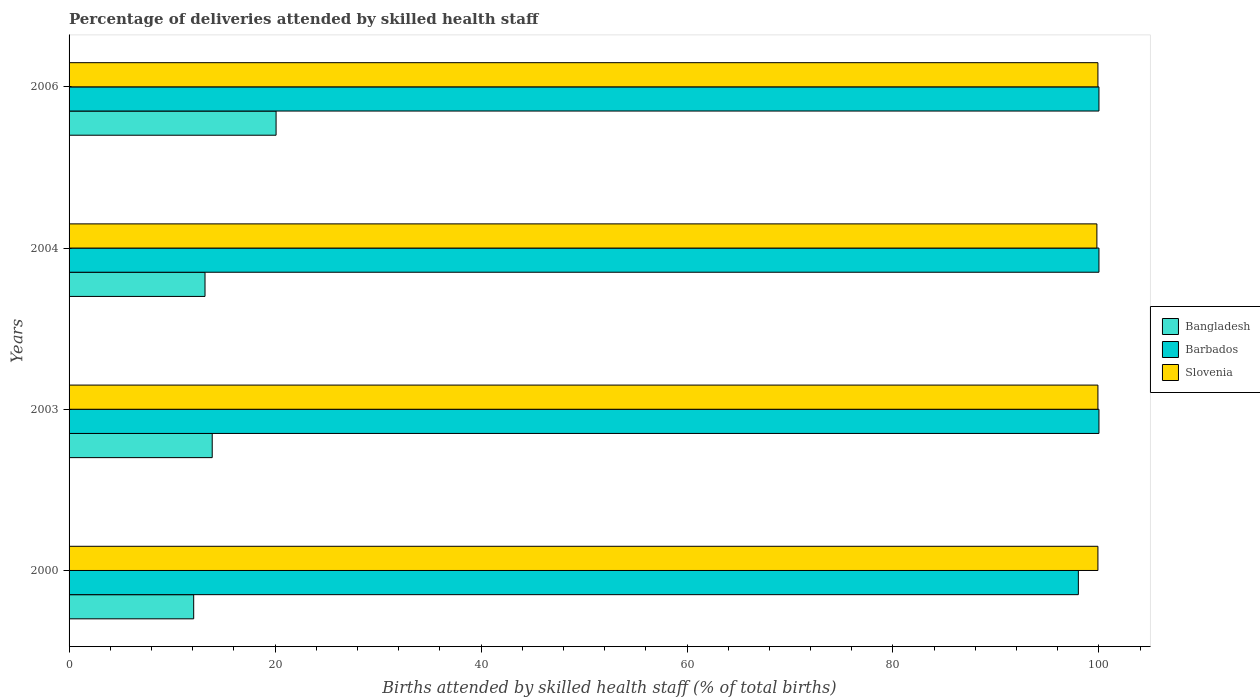Are the number of bars per tick equal to the number of legend labels?
Your answer should be very brief. Yes. Are the number of bars on each tick of the Y-axis equal?
Offer a very short reply. Yes. How many bars are there on the 1st tick from the top?
Provide a succinct answer. 3. What is the label of the 1st group of bars from the top?
Give a very brief answer. 2006. In how many cases, is the number of bars for a given year not equal to the number of legend labels?
Offer a terse response. 0. What is the percentage of births attended by skilled health staff in Bangladesh in 2003?
Provide a short and direct response. 13.9. Across all years, what is the maximum percentage of births attended by skilled health staff in Bangladesh?
Offer a terse response. 20.1. Across all years, what is the minimum percentage of births attended by skilled health staff in Bangladesh?
Offer a terse response. 12.1. In which year was the percentage of births attended by skilled health staff in Barbados minimum?
Ensure brevity in your answer.  2000. What is the total percentage of births attended by skilled health staff in Bangladesh in the graph?
Your response must be concise. 59.3. What is the difference between the percentage of births attended by skilled health staff in Slovenia in 2004 and the percentage of births attended by skilled health staff in Bangladesh in 2003?
Offer a very short reply. 85.9. What is the average percentage of births attended by skilled health staff in Barbados per year?
Your response must be concise. 99.5. In the year 2000, what is the difference between the percentage of births attended by skilled health staff in Barbados and percentage of births attended by skilled health staff in Bangladesh?
Ensure brevity in your answer.  85.9. In how many years, is the percentage of births attended by skilled health staff in Bangladesh greater than 96 %?
Make the answer very short. 0. Is the percentage of births attended by skilled health staff in Bangladesh in 2000 less than that in 2004?
Offer a terse response. Yes. Is the difference between the percentage of births attended by skilled health staff in Barbados in 2004 and 2006 greater than the difference between the percentage of births attended by skilled health staff in Bangladesh in 2004 and 2006?
Give a very brief answer. Yes. What is the difference between the highest and the second highest percentage of births attended by skilled health staff in Barbados?
Provide a short and direct response. 0. What is the difference between the highest and the lowest percentage of births attended by skilled health staff in Slovenia?
Offer a terse response. 0.1. What does the 1st bar from the top in 2006 represents?
Provide a succinct answer. Slovenia. What does the 3rd bar from the bottom in 2000 represents?
Your response must be concise. Slovenia. How many bars are there?
Your answer should be very brief. 12. Are the values on the major ticks of X-axis written in scientific E-notation?
Your answer should be very brief. No. Does the graph contain grids?
Your response must be concise. No. How are the legend labels stacked?
Your response must be concise. Vertical. What is the title of the graph?
Provide a succinct answer. Percentage of deliveries attended by skilled health staff. Does "Iraq" appear as one of the legend labels in the graph?
Give a very brief answer. No. What is the label or title of the X-axis?
Your answer should be very brief. Births attended by skilled health staff (% of total births). What is the Births attended by skilled health staff (% of total births) in Barbados in 2000?
Provide a short and direct response. 98. What is the Births attended by skilled health staff (% of total births) in Slovenia in 2000?
Keep it short and to the point. 99.9. What is the Births attended by skilled health staff (% of total births) of Bangladesh in 2003?
Provide a succinct answer. 13.9. What is the Births attended by skilled health staff (% of total births) of Barbados in 2003?
Your answer should be compact. 100. What is the Births attended by skilled health staff (% of total births) in Slovenia in 2003?
Offer a terse response. 99.9. What is the Births attended by skilled health staff (% of total births) in Barbados in 2004?
Ensure brevity in your answer.  100. What is the Births attended by skilled health staff (% of total births) of Slovenia in 2004?
Provide a short and direct response. 99.8. What is the Births attended by skilled health staff (% of total births) in Bangladesh in 2006?
Ensure brevity in your answer.  20.1. What is the Births attended by skilled health staff (% of total births) of Barbados in 2006?
Offer a very short reply. 100. What is the Births attended by skilled health staff (% of total births) in Slovenia in 2006?
Provide a succinct answer. 99.9. Across all years, what is the maximum Births attended by skilled health staff (% of total births) of Bangladesh?
Offer a very short reply. 20.1. Across all years, what is the maximum Births attended by skilled health staff (% of total births) of Barbados?
Provide a succinct answer. 100. Across all years, what is the maximum Births attended by skilled health staff (% of total births) in Slovenia?
Offer a very short reply. 99.9. Across all years, what is the minimum Births attended by skilled health staff (% of total births) of Bangladesh?
Your answer should be very brief. 12.1. Across all years, what is the minimum Births attended by skilled health staff (% of total births) of Slovenia?
Offer a very short reply. 99.8. What is the total Births attended by skilled health staff (% of total births) in Bangladesh in the graph?
Provide a short and direct response. 59.3. What is the total Births attended by skilled health staff (% of total births) of Barbados in the graph?
Keep it short and to the point. 398. What is the total Births attended by skilled health staff (% of total births) in Slovenia in the graph?
Provide a succinct answer. 399.5. What is the difference between the Births attended by skilled health staff (% of total births) in Barbados in 2000 and that in 2003?
Make the answer very short. -2. What is the difference between the Births attended by skilled health staff (% of total births) in Bangladesh in 2000 and that in 2004?
Offer a very short reply. -1.1. What is the difference between the Births attended by skilled health staff (% of total births) of Barbados in 2000 and that in 2004?
Make the answer very short. -2. What is the difference between the Births attended by skilled health staff (% of total births) of Bangladesh in 2000 and that in 2006?
Offer a very short reply. -8. What is the difference between the Births attended by skilled health staff (% of total births) of Barbados in 2000 and that in 2006?
Offer a very short reply. -2. What is the difference between the Births attended by skilled health staff (% of total births) of Slovenia in 2000 and that in 2006?
Give a very brief answer. 0. What is the difference between the Births attended by skilled health staff (% of total births) of Barbados in 2003 and that in 2004?
Your response must be concise. 0. What is the difference between the Births attended by skilled health staff (% of total births) in Slovenia in 2003 and that in 2004?
Your response must be concise. 0.1. What is the difference between the Births attended by skilled health staff (% of total births) in Bangladesh in 2003 and that in 2006?
Ensure brevity in your answer.  -6.2. What is the difference between the Births attended by skilled health staff (% of total births) in Barbados in 2003 and that in 2006?
Offer a very short reply. 0. What is the difference between the Births attended by skilled health staff (% of total births) of Bangladesh in 2000 and the Births attended by skilled health staff (% of total births) of Barbados in 2003?
Make the answer very short. -87.9. What is the difference between the Births attended by skilled health staff (% of total births) in Bangladesh in 2000 and the Births attended by skilled health staff (% of total births) in Slovenia in 2003?
Provide a short and direct response. -87.8. What is the difference between the Births attended by skilled health staff (% of total births) in Barbados in 2000 and the Births attended by skilled health staff (% of total births) in Slovenia in 2003?
Give a very brief answer. -1.9. What is the difference between the Births attended by skilled health staff (% of total births) in Bangladesh in 2000 and the Births attended by skilled health staff (% of total births) in Barbados in 2004?
Give a very brief answer. -87.9. What is the difference between the Births attended by skilled health staff (% of total births) in Bangladesh in 2000 and the Births attended by skilled health staff (% of total births) in Slovenia in 2004?
Your answer should be compact. -87.7. What is the difference between the Births attended by skilled health staff (% of total births) of Barbados in 2000 and the Births attended by skilled health staff (% of total births) of Slovenia in 2004?
Your answer should be very brief. -1.8. What is the difference between the Births attended by skilled health staff (% of total births) in Bangladesh in 2000 and the Births attended by skilled health staff (% of total births) in Barbados in 2006?
Offer a terse response. -87.9. What is the difference between the Births attended by skilled health staff (% of total births) of Bangladesh in 2000 and the Births attended by skilled health staff (% of total births) of Slovenia in 2006?
Offer a very short reply. -87.8. What is the difference between the Births attended by skilled health staff (% of total births) of Barbados in 2000 and the Births attended by skilled health staff (% of total births) of Slovenia in 2006?
Provide a succinct answer. -1.9. What is the difference between the Births attended by skilled health staff (% of total births) of Bangladesh in 2003 and the Births attended by skilled health staff (% of total births) of Barbados in 2004?
Make the answer very short. -86.1. What is the difference between the Births attended by skilled health staff (% of total births) of Bangladesh in 2003 and the Births attended by skilled health staff (% of total births) of Slovenia in 2004?
Your response must be concise. -85.9. What is the difference between the Births attended by skilled health staff (% of total births) in Bangladesh in 2003 and the Births attended by skilled health staff (% of total births) in Barbados in 2006?
Offer a terse response. -86.1. What is the difference between the Births attended by skilled health staff (% of total births) of Bangladesh in 2003 and the Births attended by skilled health staff (% of total births) of Slovenia in 2006?
Give a very brief answer. -86. What is the difference between the Births attended by skilled health staff (% of total births) of Bangladesh in 2004 and the Births attended by skilled health staff (% of total births) of Barbados in 2006?
Provide a succinct answer. -86.8. What is the difference between the Births attended by skilled health staff (% of total births) in Bangladesh in 2004 and the Births attended by skilled health staff (% of total births) in Slovenia in 2006?
Keep it short and to the point. -86.7. What is the difference between the Births attended by skilled health staff (% of total births) of Barbados in 2004 and the Births attended by skilled health staff (% of total births) of Slovenia in 2006?
Offer a terse response. 0.1. What is the average Births attended by skilled health staff (% of total births) in Bangladesh per year?
Your answer should be very brief. 14.82. What is the average Births attended by skilled health staff (% of total births) in Barbados per year?
Offer a terse response. 99.5. What is the average Births attended by skilled health staff (% of total births) in Slovenia per year?
Your answer should be very brief. 99.88. In the year 2000, what is the difference between the Births attended by skilled health staff (% of total births) of Bangladesh and Births attended by skilled health staff (% of total births) of Barbados?
Provide a short and direct response. -85.9. In the year 2000, what is the difference between the Births attended by skilled health staff (% of total births) in Bangladesh and Births attended by skilled health staff (% of total births) in Slovenia?
Your answer should be very brief. -87.8. In the year 2003, what is the difference between the Births attended by skilled health staff (% of total births) in Bangladesh and Births attended by skilled health staff (% of total births) in Barbados?
Keep it short and to the point. -86.1. In the year 2003, what is the difference between the Births attended by skilled health staff (% of total births) of Bangladesh and Births attended by skilled health staff (% of total births) of Slovenia?
Your response must be concise. -86. In the year 2003, what is the difference between the Births attended by skilled health staff (% of total births) in Barbados and Births attended by skilled health staff (% of total births) in Slovenia?
Provide a succinct answer. 0.1. In the year 2004, what is the difference between the Births attended by skilled health staff (% of total births) in Bangladesh and Births attended by skilled health staff (% of total births) in Barbados?
Offer a terse response. -86.8. In the year 2004, what is the difference between the Births attended by skilled health staff (% of total births) of Bangladesh and Births attended by skilled health staff (% of total births) of Slovenia?
Provide a short and direct response. -86.6. In the year 2006, what is the difference between the Births attended by skilled health staff (% of total births) in Bangladesh and Births attended by skilled health staff (% of total births) in Barbados?
Your answer should be very brief. -79.9. In the year 2006, what is the difference between the Births attended by skilled health staff (% of total births) in Bangladesh and Births attended by skilled health staff (% of total births) in Slovenia?
Provide a succinct answer. -79.8. What is the ratio of the Births attended by skilled health staff (% of total births) in Bangladesh in 2000 to that in 2003?
Offer a very short reply. 0.87. What is the ratio of the Births attended by skilled health staff (% of total births) in Barbados in 2000 to that in 2003?
Your answer should be compact. 0.98. What is the ratio of the Births attended by skilled health staff (% of total births) of Slovenia in 2000 to that in 2003?
Provide a short and direct response. 1. What is the ratio of the Births attended by skilled health staff (% of total births) in Bangladesh in 2000 to that in 2004?
Your answer should be very brief. 0.92. What is the ratio of the Births attended by skilled health staff (% of total births) of Slovenia in 2000 to that in 2004?
Provide a succinct answer. 1. What is the ratio of the Births attended by skilled health staff (% of total births) in Bangladesh in 2000 to that in 2006?
Offer a very short reply. 0.6. What is the ratio of the Births attended by skilled health staff (% of total births) of Bangladesh in 2003 to that in 2004?
Give a very brief answer. 1.05. What is the ratio of the Births attended by skilled health staff (% of total births) in Barbados in 2003 to that in 2004?
Offer a terse response. 1. What is the ratio of the Births attended by skilled health staff (% of total births) in Bangladesh in 2003 to that in 2006?
Offer a very short reply. 0.69. What is the ratio of the Births attended by skilled health staff (% of total births) in Barbados in 2003 to that in 2006?
Your answer should be very brief. 1. What is the ratio of the Births attended by skilled health staff (% of total births) of Slovenia in 2003 to that in 2006?
Keep it short and to the point. 1. What is the ratio of the Births attended by skilled health staff (% of total births) of Bangladesh in 2004 to that in 2006?
Your response must be concise. 0.66. What is the ratio of the Births attended by skilled health staff (% of total births) of Barbados in 2004 to that in 2006?
Your response must be concise. 1. What is the ratio of the Births attended by skilled health staff (% of total births) of Slovenia in 2004 to that in 2006?
Your answer should be very brief. 1. What is the difference between the highest and the second highest Births attended by skilled health staff (% of total births) of Bangladesh?
Make the answer very short. 6.2. What is the difference between the highest and the second highest Births attended by skilled health staff (% of total births) in Barbados?
Offer a terse response. 0. What is the difference between the highest and the second highest Births attended by skilled health staff (% of total births) in Slovenia?
Offer a very short reply. 0. What is the difference between the highest and the lowest Births attended by skilled health staff (% of total births) of Slovenia?
Give a very brief answer. 0.1. 